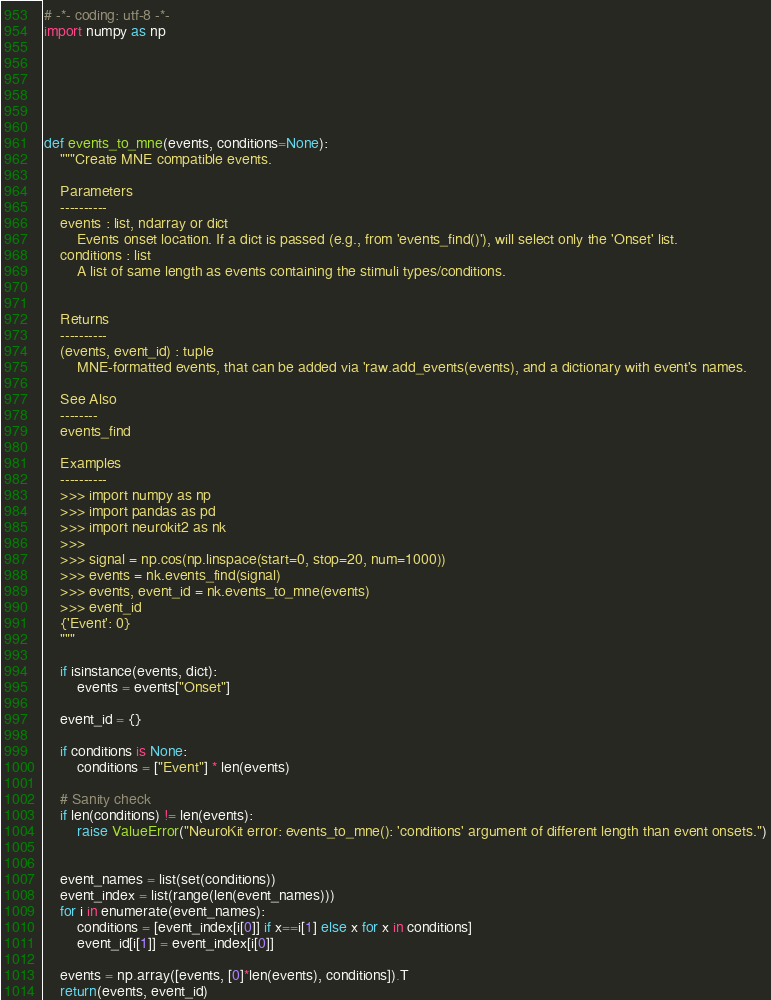Convert code to text. <code><loc_0><loc_0><loc_500><loc_500><_Python_># -*- coding: utf-8 -*-
import numpy as np






def events_to_mne(events, conditions=None):
    """Create MNE compatible events.

    Parameters
    ----------
    events : list, ndarray or dict
        Events onset location. If a dict is passed (e.g., from 'events_find()'), will select only the 'Onset' list.
    conditions : list
        A list of same length as events containing the stimuli types/conditions.


    Returns
    ----------
    (events, event_id) : tuple
        MNE-formatted events, that can be added via 'raw.add_events(events), and a dictionary with event's names.

    See Also
    --------
    events_find

    Examples
    ----------
    >>> import numpy as np
    >>> import pandas as pd
    >>> import neurokit2 as nk
    >>>
    >>> signal = np.cos(np.linspace(start=0, stop=20, num=1000))
    >>> events = nk.events_find(signal)
    >>> events, event_id = nk.events_to_mne(events)
    >>> event_id
    {'Event': 0}
    """

    if isinstance(events, dict):
        events = events["Onset"]

    event_id = {}

    if conditions is None:
        conditions = ["Event"] * len(events)

    # Sanity check
    if len(conditions) != len(events):
        raise ValueError("NeuroKit error: events_to_mne(): 'conditions' argument of different length than event onsets.")


    event_names = list(set(conditions))
    event_index = list(range(len(event_names)))
    for i in enumerate(event_names):
        conditions = [event_index[i[0]] if x==i[1] else x for x in conditions]
        event_id[i[1]] = event_index[i[0]]

    events = np.array([events, [0]*len(events), conditions]).T
    return(events, event_id)
</code> 